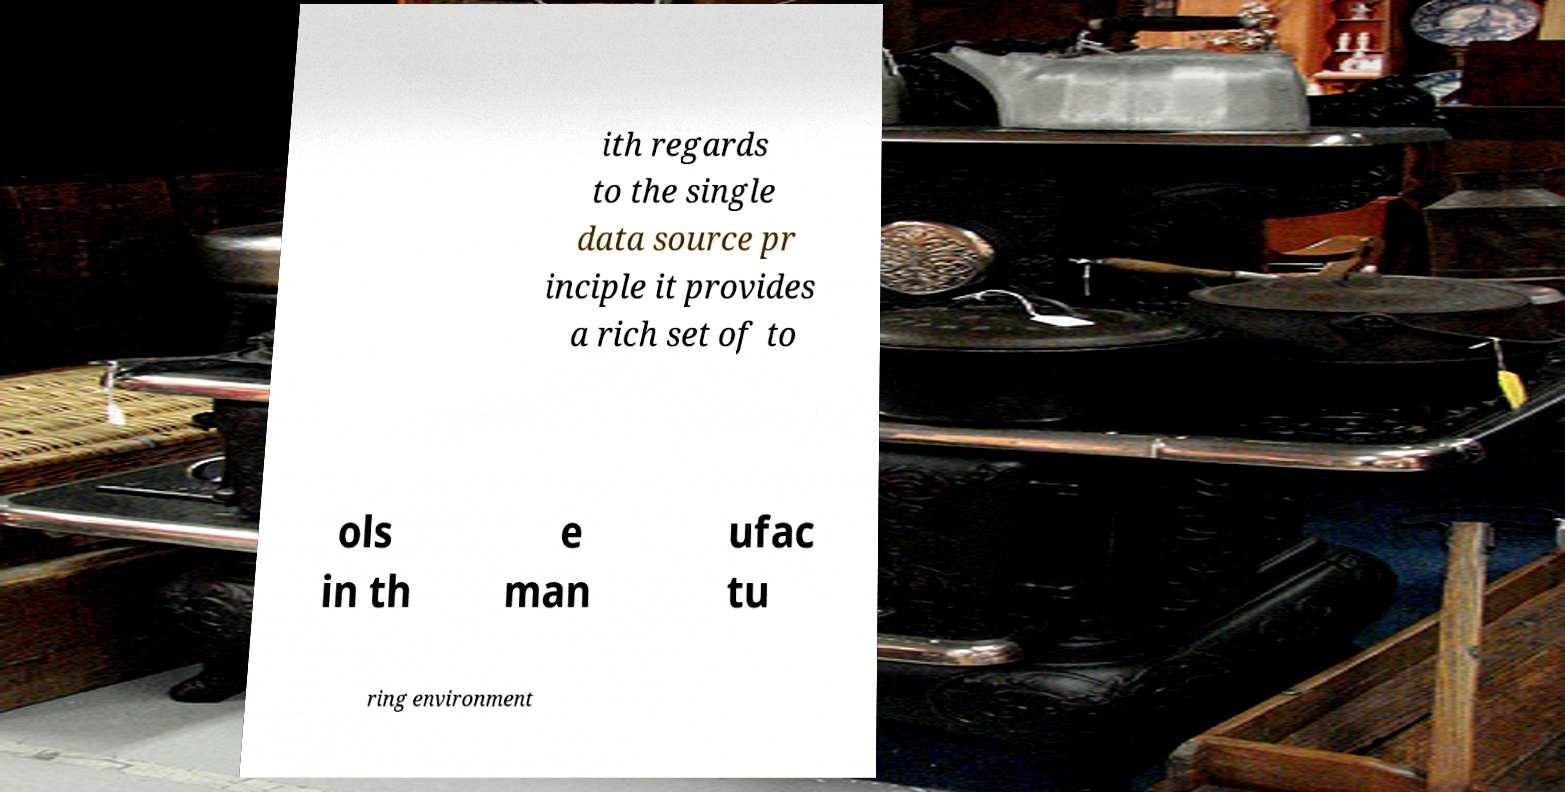Can you accurately transcribe the text from the provided image for me? ith regards to the single data source pr inciple it provides a rich set of to ols in th e man ufac tu ring environment 